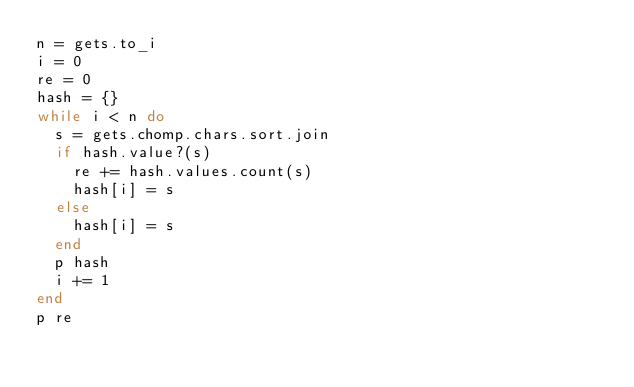Convert code to text. <code><loc_0><loc_0><loc_500><loc_500><_Ruby_>n = gets.to_i
i = 0
re = 0
hash = {}
while i < n do 
  s = gets.chomp.chars.sort.join
  if hash.value?(s) 
    re += hash.values.count(s)
    hash[i] = s
  else
    hash[i] = s
  end
  p hash
  i += 1
end
p re</code> 